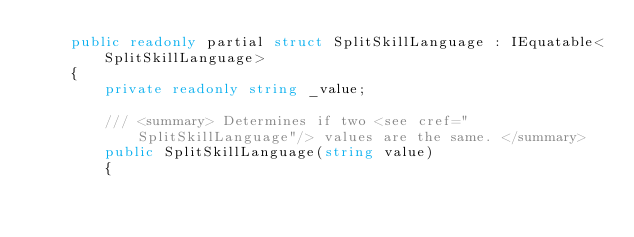<code> <loc_0><loc_0><loc_500><loc_500><_C#_>    public readonly partial struct SplitSkillLanguage : IEquatable<SplitSkillLanguage>
    {
        private readonly string _value;

        /// <summary> Determines if two <see cref="SplitSkillLanguage"/> values are the same. </summary>
        public SplitSkillLanguage(string value)
        {</code> 